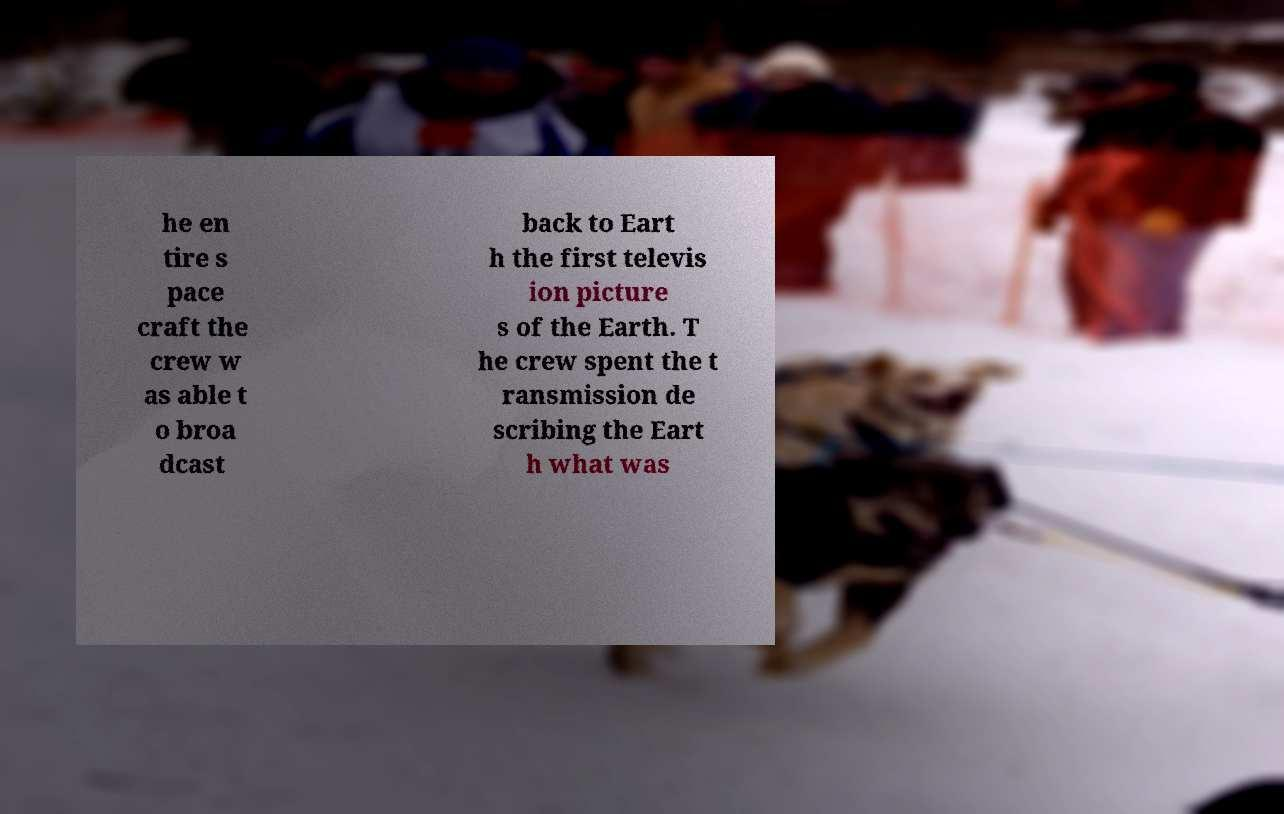Can you accurately transcribe the text from the provided image for me? he en tire s pace craft the crew w as able t o broa dcast back to Eart h the first televis ion picture s of the Earth. T he crew spent the t ransmission de scribing the Eart h what was 